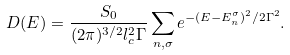<formula> <loc_0><loc_0><loc_500><loc_500>D ( E ) = \frac { S _ { 0 } } { ( 2 \pi ) ^ { 3 / 2 } l _ { c } ^ { 2 } \Gamma } \sum _ { n , \sigma } e ^ { - ( E - E _ { n } ^ { \sigma } ) ^ { 2 } / 2 \Gamma ^ { 2 } } .</formula> 